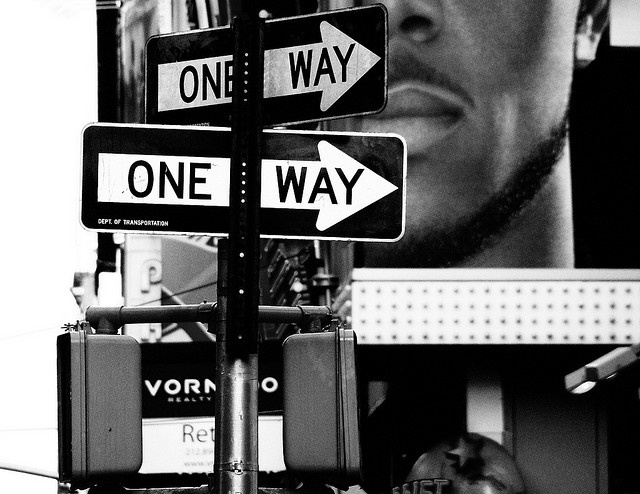Describe the objects in this image and their specific colors. I can see a traffic light in white, gray, black, darkgray, and lightgray tones in this image. 